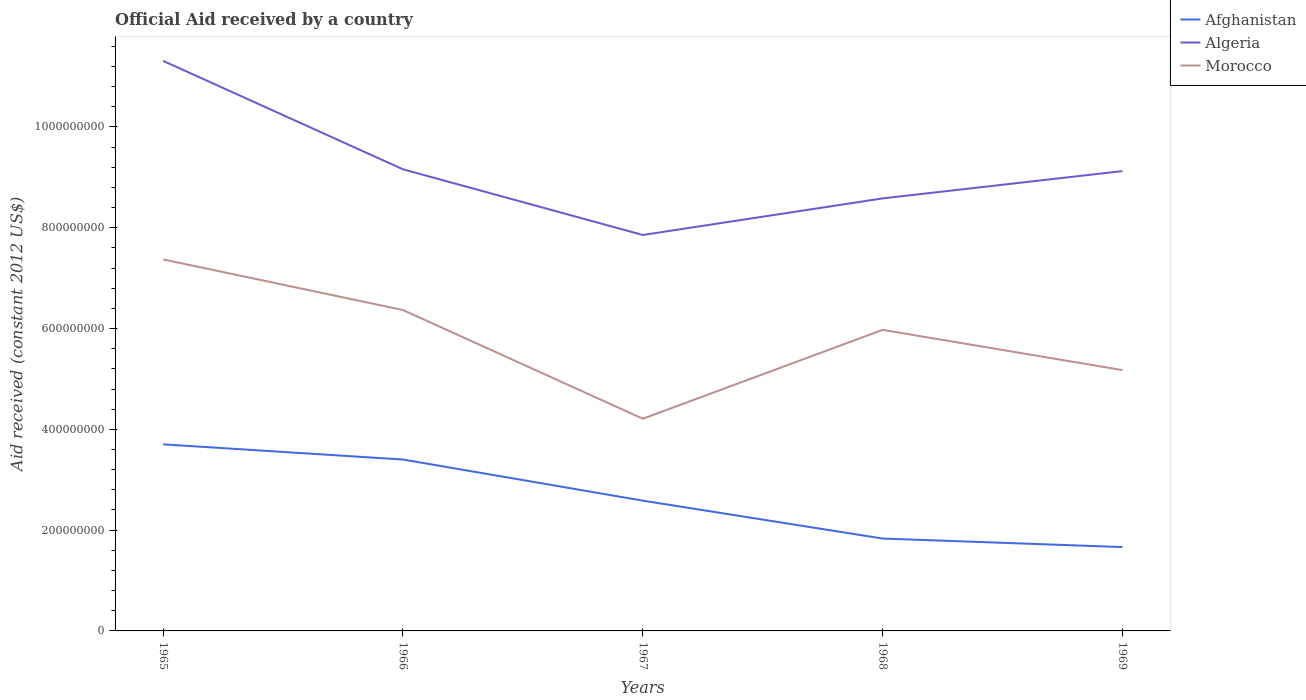How many different coloured lines are there?
Your answer should be very brief. 3. Does the line corresponding to Algeria intersect with the line corresponding to Morocco?
Give a very brief answer. No. Is the number of lines equal to the number of legend labels?
Offer a terse response. Yes. Across all years, what is the maximum net official aid received in Algeria?
Your answer should be very brief. 7.86e+08. In which year was the net official aid received in Afghanistan maximum?
Make the answer very short. 1969. What is the total net official aid received in Morocco in the graph?
Your answer should be compact. 2.20e+08. What is the difference between the highest and the second highest net official aid received in Algeria?
Ensure brevity in your answer.  3.45e+08. What is the difference between two consecutive major ticks on the Y-axis?
Provide a succinct answer. 2.00e+08. Does the graph contain grids?
Give a very brief answer. No. What is the title of the graph?
Your response must be concise. Official Aid received by a country. What is the label or title of the X-axis?
Give a very brief answer. Years. What is the label or title of the Y-axis?
Your response must be concise. Aid received (constant 2012 US$). What is the Aid received (constant 2012 US$) in Afghanistan in 1965?
Your response must be concise. 3.70e+08. What is the Aid received (constant 2012 US$) of Algeria in 1965?
Offer a terse response. 1.13e+09. What is the Aid received (constant 2012 US$) in Morocco in 1965?
Keep it short and to the point. 7.37e+08. What is the Aid received (constant 2012 US$) of Afghanistan in 1966?
Offer a terse response. 3.40e+08. What is the Aid received (constant 2012 US$) of Algeria in 1966?
Offer a very short reply. 9.16e+08. What is the Aid received (constant 2012 US$) of Morocco in 1966?
Offer a terse response. 6.37e+08. What is the Aid received (constant 2012 US$) in Afghanistan in 1967?
Offer a terse response. 2.59e+08. What is the Aid received (constant 2012 US$) in Algeria in 1967?
Keep it short and to the point. 7.86e+08. What is the Aid received (constant 2012 US$) in Morocco in 1967?
Your response must be concise. 4.21e+08. What is the Aid received (constant 2012 US$) of Afghanistan in 1968?
Your answer should be compact. 1.83e+08. What is the Aid received (constant 2012 US$) in Algeria in 1968?
Offer a terse response. 8.58e+08. What is the Aid received (constant 2012 US$) of Morocco in 1968?
Give a very brief answer. 5.97e+08. What is the Aid received (constant 2012 US$) in Afghanistan in 1969?
Your answer should be very brief. 1.66e+08. What is the Aid received (constant 2012 US$) in Algeria in 1969?
Provide a succinct answer. 9.12e+08. What is the Aid received (constant 2012 US$) of Morocco in 1969?
Provide a succinct answer. 5.18e+08. Across all years, what is the maximum Aid received (constant 2012 US$) in Afghanistan?
Offer a very short reply. 3.70e+08. Across all years, what is the maximum Aid received (constant 2012 US$) of Algeria?
Your answer should be compact. 1.13e+09. Across all years, what is the maximum Aid received (constant 2012 US$) of Morocco?
Make the answer very short. 7.37e+08. Across all years, what is the minimum Aid received (constant 2012 US$) in Afghanistan?
Provide a succinct answer. 1.66e+08. Across all years, what is the minimum Aid received (constant 2012 US$) of Algeria?
Your answer should be compact. 7.86e+08. Across all years, what is the minimum Aid received (constant 2012 US$) in Morocco?
Your answer should be compact. 4.21e+08. What is the total Aid received (constant 2012 US$) of Afghanistan in the graph?
Give a very brief answer. 1.32e+09. What is the total Aid received (constant 2012 US$) of Algeria in the graph?
Give a very brief answer. 4.60e+09. What is the total Aid received (constant 2012 US$) of Morocco in the graph?
Ensure brevity in your answer.  2.91e+09. What is the difference between the Aid received (constant 2012 US$) in Afghanistan in 1965 and that in 1966?
Make the answer very short. 3.02e+07. What is the difference between the Aid received (constant 2012 US$) of Algeria in 1965 and that in 1966?
Your answer should be very brief. 2.15e+08. What is the difference between the Aid received (constant 2012 US$) of Morocco in 1965 and that in 1966?
Your answer should be very brief. 1.00e+08. What is the difference between the Aid received (constant 2012 US$) of Afghanistan in 1965 and that in 1967?
Offer a very short reply. 1.12e+08. What is the difference between the Aid received (constant 2012 US$) of Algeria in 1965 and that in 1967?
Keep it short and to the point. 3.45e+08. What is the difference between the Aid received (constant 2012 US$) in Morocco in 1965 and that in 1967?
Provide a succinct answer. 3.16e+08. What is the difference between the Aid received (constant 2012 US$) in Afghanistan in 1965 and that in 1968?
Give a very brief answer. 1.87e+08. What is the difference between the Aid received (constant 2012 US$) in Algeria in 1965 and that in 1968?
Provide a short and direct response. 2.73e+08. What is the difference between the Aid received (constant 2012 US$) in Morocco in 1965 and that in 1968?
Offer a very short reply. 1.40e+08. What is the difference between the Aid received (constant 2012 US$) in Afghanistan in 1965 and that in 1969?
Make the answer very short. 2.04e+08. What is the difference between the Aid received (constant 2012 US$) of Algeria in 1965 and that in 1969?
Your answer should be compact. 2.19e+08. What is the difference between the Aid received (constant 2012 US$) in Morocco in 1965 and that in 1969?
Offer a very short reply. 2.20e+08. What is the difference between the Aid received (constant 2012 US$) in Afghanistan in 1966 and that in 1967?
Your answer should be compact. 8.16e+07. What is the difference between the Aid received (constant 2012 US$) of Algeria in 1966 and that in 1967?
Make the answer very short. 1.30e+08. What is the difference between the Aid received (constant 2012 US$) of Morocco in 1966 and that in 1967?
Provide a short and direct response. 2.16e+08. What is the difference between the Aid received (constant 2012 US$) of Afghanistan in 1966 and that in 1968?
Keep it short and to the point. 1.57e+08. What is the difference between the Aid received (constant 2012 US$) of Algeria in 1966 and that in 1968?
Your answer should be very brief. 5.77e+07. What is the difference between the Aid received (constant 2012 US$) of Morocco in 1966 and that in 1968?
Provide a succinct answer. 3.94e+07. What is the difference between the Aid received (constant 2012 US$) in Afghanistan in 1966 and that in 1969?
Offer a terse response. 1.74e+08. What is the difference between the Aid received (constant 2012 US$) in Algeria in 1966 and that in 1969?
Provide a succinct answer. 3.54e+06. What is the difference between the Aid received (constant 2012 US$) in Morocco in 1966 and that in 1969?
Offer a terse response. 1.19e+08. What is the difference between the Aid received (constant 2012 US$) of Afghanistan in 1967 and that in 1968?
Ensure brevity in your answer.  7.52e+07. What is the difference between the Aid received (constant 2012 US$) in Algeria in 1967 and that in 1968?
Keep it short and to the point. -7.26e+07. What is the difference between the Aid received (constant 2012 US$) in Morocco in 1967 and that in 1968?
Your answer should be very brief. -1.76e+08. What is the difference between the Aid received (constant 2012 US$) in Afghanistan in 1967 and that in 1969?
Your answer should be compact. 9.21e+07. What is the difference between the Aid received (constant 2012 US$) of Algeria in 1967 and that in 1969?
Your response must be concise. -1.27e+08. What is the difference between the Aid received (constant 2012 US$) of Morocco in 1967 and that in 1969?
Provide a succinct answer. -9.65e+07. What is the difference between the Aid received (constant 2012 US$) in Afghanistan in 1968 and that in 1969?
Your response must be concise. 1.69e+07. What is the difference between the Aid received (constant 2012 US$) of Algeria in 1968 and that in 1969?
Provide a short and direct response. -5.42e+07. What is the difference between the Aid received (constant 2012 US$) of Morocco in 1968 and that in 1969?
Your response must be concise. 7.99e+07. What is the difference between the Aid received (constant 2012 US$) in Afghanistan in 1965 and the Aid received (constant 2012 US$) in Algeria in 1966?
Your answer should be compact. -5.46e+08. What is the difference between the Aid received (constant 2012 US$) in Afghanistan in 1965 and the Aid received (constant 2012 US$) in Morocco in 1966?
Provide a short and direct response. -2.67e+08. What is the difference between the Aid received (constant 2012 US$) of Algeria in 1965 and the Aid received (constant 2012 US$) of Morocco in 1966?
Your response must be concise. 4.94e+08. What is the difference between the Aid received (constant 2012 US$) in Afghanistan in 1965 and the Aid received (constant 2012 US$) in Algeria in 1967?
Your answer should be very brief. -4.15e+08. What is the difference between the Aid received (constant 2012 US$) in Afghanistan in 1965 and the Aid received (constant 2012 US$) in Morocco in 1967?
Your answer should be very brief. -5.08e+07. What is the difference between the Aid received (constant 2012 US$) of Algeria in 1965 and the Aid received (constant 2012 US$) of Morocco in 1967?
Keep it short and to the point. 7.10e+08. What is the difference between the Aid received (constant 2012 US$) of Afghanistan in 1965 and the Aid received (constant 2012 US$) of Algeria in 1968?
Give a very brief answer. -4.88e+08. What is the difference between the Aid received (constant 2012 US$) in Afghanistan in 1965 and the Aid received (constant 2012 US$) in Morocco in 1968?
Your answer should be compact. -2.27e+08. What is the difference between the Aid received (constant 2012 US$) of Algeria in 1965 and the Aid received (constant 2012 US$) of Morocco in 1968?
Ensure brevity in your answer.  5.34e+08. What is the difference between the Aid received (constant 2012 US$) of Afghanistan in 1965 and the Aid received (constant 2012 US$) of Algeria in 1969?
Offer a very short reply. -5.42e+08. What is the difference between the Aid received (constant 2012 US$) in Afghanistan in 1965 and the Aid received (constant 2012 US$) in Morocco in 1969?
Your response must be concise. -1.47e+08. What is the difference between the Aid received (constant 2012 US$) in Algeria in 1965 and the Aid received (constant 2012 US$) in Morocco in 1969?
Provide a short and direct response. 6.14e+08. What is the difference between the Aid received (constant 2012 US$) of Afghanistan in 1966 and the Aid received (constant 2012 US$) of Algeria in 1967?
Provide a short and direct response. -4.46e+08. What is the difference between the Aid received (constant 2012 US$) in Afghanistan in 1966 and the Aid received (constant 2012 US$) in Morocco in 1967?
Your answer should be very brief. -8.10e+07. What is the difference between the Aid received (constant 2012 US$) in Algeria in 1966 and the Aid received (constant 2012 US$) in Morocco in 1967?
Offer a very short reply. 4.95e+08. What is the difference between the Aid received (constant 2012 US$) in Afghanistan in 1966 and the Aid received (constant 2012 US$) in Algeria in 1968?
Provide a succinct answer. -5.18e+08. What is the difference between the Aid received (constant 2012 US$) of Afghanistan in 1966 and the Aid received (constant 2012 US$) of Morocco in 1968?
Your response must be concise. -2.57e+08. What is the difference between the Aid received (constant 2012 US$) of Algeria in 1966 and the Aid received (constant 2012 US$) of Morocco in 1968?
Give a very brief answer. 3.19e+08. What is the difference between the Aid received (constant 2012 US$) of Afghanistan in 1966 and the Aid received (constant 2012 US$) of Algeria in 1969?
Offer a very short reply. -5.72e+08. What is the difference between the Aid received (constant 2012 US$) in Afghanistan in 1966 and the Aid received (constant 2012 US$) in Morocco in 1969?
Make the answer very short. -1.77e+08. What is the difference between the Aid received (constant 2012 US$) of Algeria in 1966 and the Aid received (constant 2012 US$) of Morocco in 1969?
Your answer should be compact. 3.98e+08. What is the difference between the Aid received (constant 2012 US$) of Afghanistan in 1967 and the Aid received (constant 2012 US$) of Algeria in 1968?
Your answer should be compact. -6.00e+08. What is the difference between the Aid received (constant 2012 US$) in Afghanistan in 1967 and the Aid received (constant 2012 US$) in Morocco in 1968?
Your answer should be compact. -3.39e+08. What is the difference between the Aid received (constant 2012 US$) in Algeria in 1967 and the Aid received (constant 2012 US$) in Morocco in 1968?
Keep it short and to the point. 1.88e+08. What is the difference between the Aid received (constant 2012 US$) in Afghanistan in 1967 and the Aid received (constant 2012 US$) in Algeria in 1969?
Your response must be concise. -6.54e+08. What is the difference between the Aid received (constant 2012 US$) of Afghanistan in 1967 and the Aid received (constant 2012 US$) of Morocco in 1969?
Provide a short and direct response. -2.59e+08. What is the difference between the Aid received (constant 2012 US$) of Algeria in 1967 and the Aid received (constant 2012 US$) of Morocco in 1969?
Give a very brief answer. 2.68e+08. What is the difference between the Aid received (constant 2012 US$) in Afghanistan in 1968 and the Aid received (constant 2012 US$) in Algeria in 1969?
Your response must be concise. -7.29e+08. What is the difference between the Aid received (constant 2012 US$) of Afghanistan in 1968 and the Aid received (constant 2012 US$) of Morocco in 1969?
Your answer should be very brief. -3.34e+08. What is the difference between the Aid received (constant 2012 US$) of Algeria in 1968 and the Aid received (constant 2012 US$) of Morocco in 1969?
Keep it short and to the point. 3.41e+08. What is the average Aid received (constant 2012 US$) in Afghanistan per year?
Your response must be concise. 2.64e+08. What is the average Aid received (constant 2012 US$) in Algeria per year?
Your answer should be very brief. 9.21e+08. What is the average Aid received (constant 2012 US$) in Morocco per year?
Your answer should be very brief. 5.82e+08. In the year 1965, what is the difference between the Aid received (constant 2012 US$) of Afghanistan and Aid received (constant 2012 US$) of Algeria?
Make the answer very short. -7.61e+08. In the year 1965, what is the difference between the Aid received (constant 2012 US$) in Afghanistan and Aid received (constant 2012 US$) in Morocco?
Your response must be concise. -3.67e+08. In the year 1965, what is the difference between the Aid received (constant 2012 US$) of Algeria and Aid received (constant 2012 US$) of Morocco?
Your response must be concise. 3.94e+08. In the year 1966, what is the difference between the Aid received (constant 2012 US$) of Afghanistan and Aid received (constant 2012 US$) of Algeria?
Give a very brief answer. -5.76e+08. In the year 1966, what is the difference between the Aid received (constant 2012 US$) of Afghanistan and Aid received (constant 2012 US$) of Morocco?
Your response must be concise. -2.97e+08. In the year 1966, what is the difference between the Aid received (constant 2012 US$) of Algeria and Aid received (constant 2012 US$) of Morocco?
Offer a very short reply. 2.79e+08. In the year 1967, what is the difference between the Aid received (constant 2012 US$) in Afghanistan and Aid received (constant 2012 US$) in Algeria?
Provide a short and direct response. -5.27e+08. In the year 1967, what is the difference between the Aid received (constant 2012 US$) of Afghanistan and Aid received (constant 2012 US$) of Morocco?
Give a very brief answer. -1.63e+08. In the year 1967, what is the difference between the Aid received (constant 2012 US$) in Algeria and Aid received (constant 2012 US$) in Morocco?
Your answer should be compact. 3.65e+08. In the year 1968, what is the difference between the Aid received (constant 2012 US$) in Afghanistan and Aid received (constant 2012 US$) in Algeria?
Your response must be concise. -6.75e+08. In the year 1968, what is the difference between the Aid received (constant 2012 US$) in Afghanistan and Aid received (constant 2012 US$) in Morocco?
Offer a very short reply. -4.14e+08. In the year 1968, what is the difference between the Aid received (constant 2012 US$) of Algeria and Aid received (constant 2012 US$) of Morocco?
Offer a very short reply. 2.61e+08. In the year 1969, what is the difference between the Aid received (constant 2012 US$) of Afghanistan and Aid received (constant 2012 US$) of Algeria?
Offer a terse response. -7.46e+08. In the year 1969, what is the difference between the Aid received (constant 2012 US$) in Afghanistan and Aid received (constant 2012 US$) in Morocco?
Give a very brief answer. -3.51e+08. In the year 1969, what is the difference between the Aid received (constant 2012 US$) in Algeria and Aid received (constant 2012 US$) in Morocco?
Offer a very short reply. 3.95e+08. What is the ratio of the Aid received (constant 2012 US$) of Afghanistan in 1965 to that in 1966?
Keep it short and to the point. 1.09. What is the ratio of the Aid received (constant 2012 US$) in Algeria in 1965 to that in 1966?
Offer a terse response. 1.23. What is the ratio of the Aid received (constant 2012 US$) of Morocco in 1965 to that in 1966?
Your answer should be very brief. 1.16. What is the ratio of the Aid received (constant 2012 US$) in Afghanistan in 1965 to that in 1967?
Keep it short and to the point. 1.43. What is the ratio of the Aid received (constant 2012 US$) of Algeria in 1965 to that in 1967?
Make the answer very short. 1.44. What is the ratio of the Aid received (constant 2012 US$) of Morocco in 1965 to that in 1967?
Your response must be concise. 1.75. What is the ratio of the Aid received (constant 2012 US$) in Afghanistan in 1965 to that in 1968?
Ensure brevity in your answer.  2.02. What is the ratio of the Aid received (constant 2012 US$) in Algeria in 1965 to that in 1968?
Provide a short and direct response. 1.32. What is the ratio of the Aid received (constant 2012 US$) of Morocco in 1965 to that in 1968?
Keep it short and to the point. 1.23. What is the ratio of the Aid received (constant 2012 US$) of Afghanistan in 1965 to that in 1969?
Your response must be concise. 2.23. What is the ratio of the Aid received (constant 2012 US$) in Algeria in 1965 to that in 1969?
Offer a terse response. 1.24. What is the ratio of the Aid received (constant 2012 US$) in Morocco in 1965 to that in 1969?
Your answer should be very brief. 1.42. What is the ratio of the Aid received (constant 2012 US$) of Afghanistan in 1966 to that in 1967?
Keep it short and to the point. 1.32. What is the ratio of the Aid received (constant 2012 US$) of Algeria in 1966 to that in 1967?
Offer a terse response. 1.17. What is the ratio of the Aid received (constant 2012 US$) of Morocco in 1966 to that in 1967?
Your response must be concise. 1.51. What is the ratio of the Aid received (constant 2012 US$) of Afghanistan in 1966 to that in 1968?
Provide a short and direct response. 1.86. What is the ratio of the Aid received (constant 2012 US$) of Algeria in 1966 to that in 1968?
Provide a short and direct response. 1.07. What is the ratio of the Aid received (constant 2012 US$) of Morocco in 1966 to that in 1968?
Your answer should be compact. 1.07. What is the ratio of the Aid received (constant 2012 US$) in Afghanistan in 1966 to that in 1969?
Offer a very short reply. 2.04. What is the ratio of the Aid received (constant 2012 US$) of Morocco in 1966 to that in 1969?
Provide a short and direct response. 1.23. What is the ratio of the Aid received (constant 2012 US$) of Afghanistan in 1967 to that in 1968?
Provide a succinct answer. 1.41. What is the ratio of the Aid received (constant 2012 US$) of Algeria in 1967 to that in 1968?
Offer a terse response. 0.92. What is the ratio of the Aid received (constant 2012 US$) of Morocco in 1967 to that in 1968?
Keep it short and to the point. 0.7. What is the ratio of the Aid received (constant 2012 US$) in Afghanistan in 1967 to that in 1969?
Your response must be concise. 1.55. What is the ratio of the Aid received (constant 2012 US$) of Algeria in 1967 to that in 1969?
Your response must be concise. 0.86. What is the ratio of the Aid received (constant 2012 US$) in Morocco in 1967 to that in 1969?
Keep it short and to the point. 0.81. What is the ratio of the Aid received (constant 2012 US$) of Afghanistan in 1968 to that in 1969?
Provide a short and direct response. 1.1. What is the ratio of the Aid received (constant 2012 US$) in Algeria in 1968 to that in 1969?
Provide a short and direct response. 0.94. What is the ratio of the Aid received (constant 2012 US$) in Morocco in 1968 to that in 1969?
Provide a short and direct response. 1.15. What is the difference between the highest and the second highest Aid received (constant 2012 US$) in Afghanistan?
Your response must be concise. 3.02e+07. What is the difference between the highest and the second highest Aid received (constant 2012 US$) in Algeria?
Provide a short and direct response. 2.15e+08. What is the difference between the highest and the second highest Aid received (constant 2012 US$) in Morocco?
Offer a very short reply. 1.00e+08. What is the difference between the highest and the lowest Aid received (constant 2012 US$) in Afghanistan?
Your answer should be compact. 2.04e+08. What is the difference between the highest and the lowest Aid received (constant 2012 US$) in Algeria?
Provide a succinct answer. 3.45e+08. What is the difference between the highest and the lowest Aid received (constant 2012 US$) in Morocco?
Your response must be concise. 3.16e+08. 